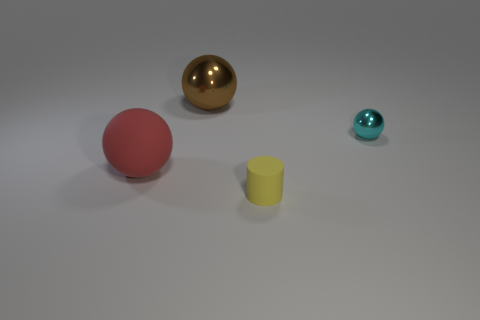Is there anything else that is the same color as the large matte thing?
Your answer should be very brief. No. What is the shape of the large thing that is the same material as the small yellow cylinder?
Your response must be concise. Sphere. Do the big rubber object and the tiny ball have the same color?
Keep it short and to the point. No. Is the sphere that is to the left of the brown sphere made of the same material as the sphere that is right of the big brown sphere?
Provide a succinct answer. No. How many things are either small yellow objects or small objects behind the rubber ball?
Offer a terse response. 2. Is there anything else that has the same material as the small cylinder?
Your answer should be compact. Yes. What is the material of the big brown ball?
Ensure brevity in your answer.  Metal. Does the cyan ball have the same material as the cylinder?
Provide a succinct answer. No. How many metallic things are tiny red cubes or yellow objects?
Keep it short and to the point. 0. There is a metallic thing on the left side of the yellow rubber cylinder; what shape is it?
Offer a very short reply. Sphere. 